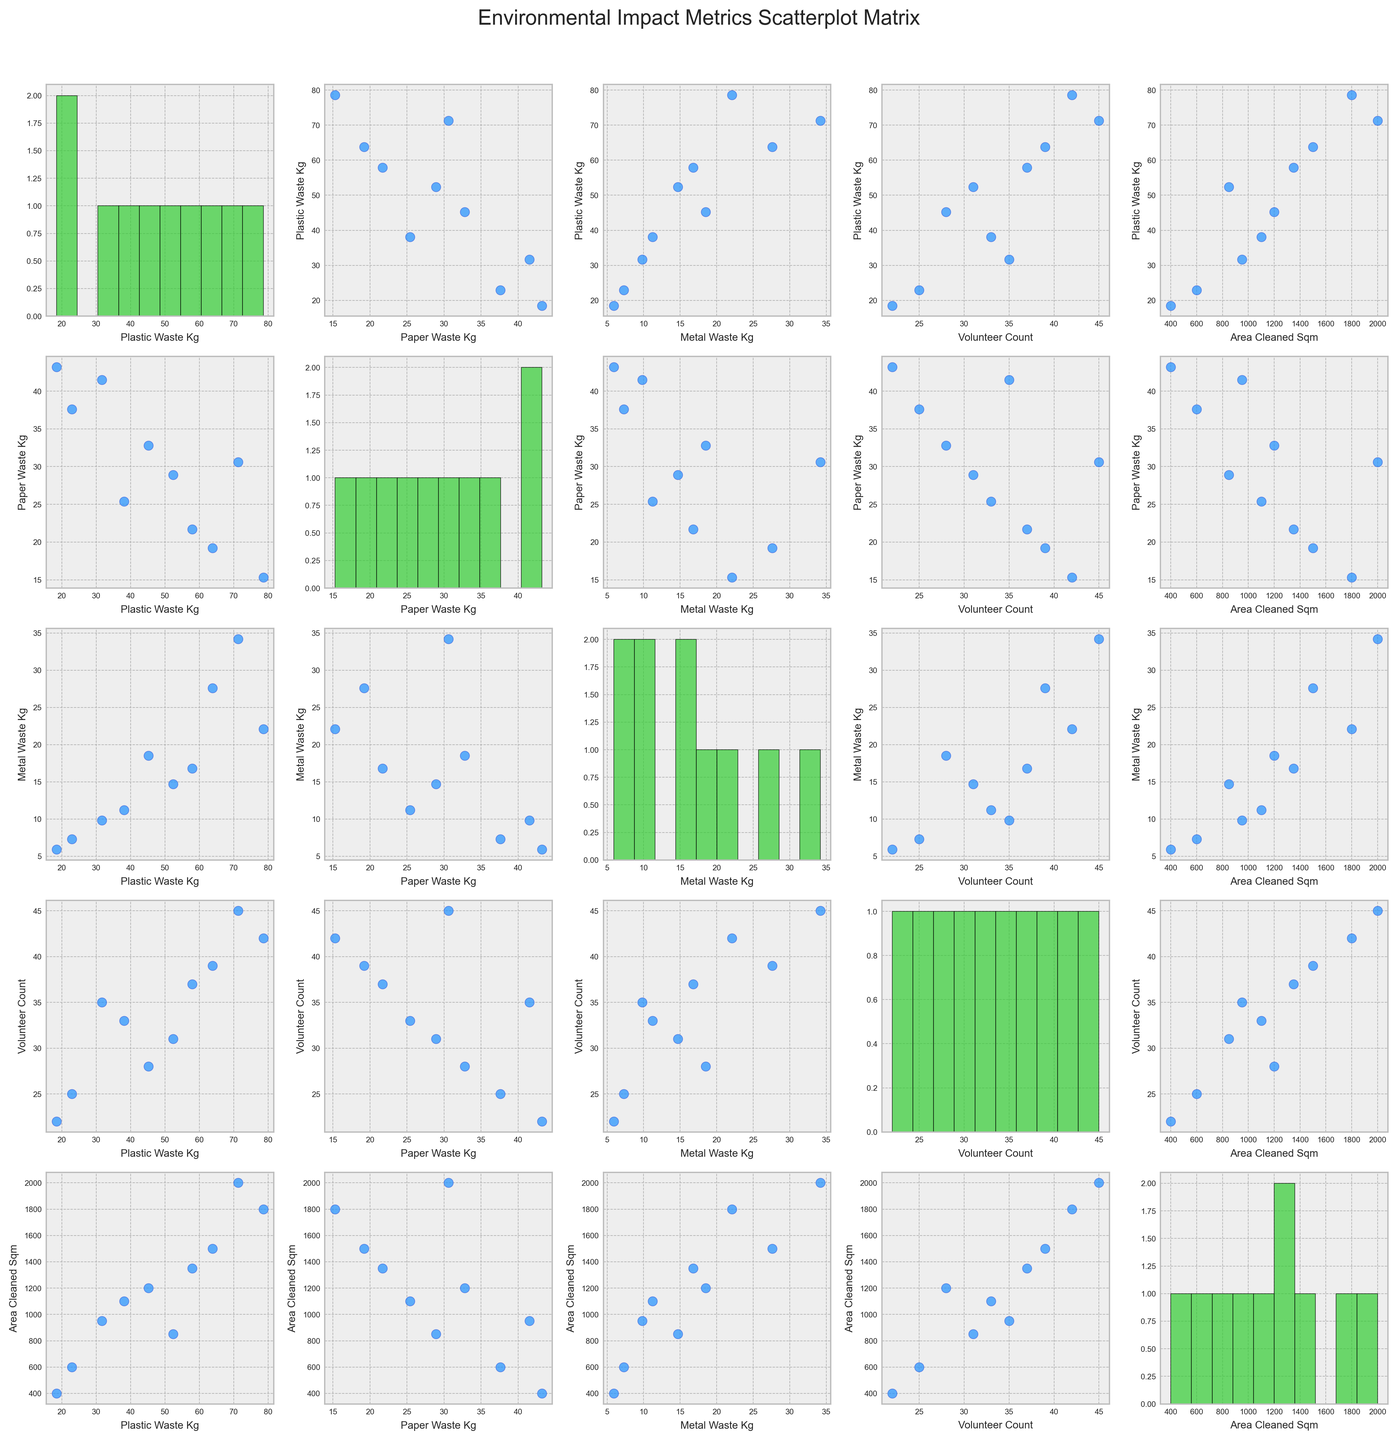What's the main color of the scatter points in the figure? The scatter points are mainly colored in shades of blue, which can be seen in the scatter plots comparing different metrics.
Answer: Blue What's the x-axis label when comparing Plastic Waste Kg to Volunteer Count? The x-axis label is "Volunteer Count" as seen in the scatter plot between Plastic_Waste_Kg and Volunteer_Count.
Answer: Volunteer Count How many scatter plots are there in the entire scatterplot matrix? The scatterplot matrix compares 5 variables, which means there are a 5x5 grid of plots. Since the diagonal contains histograms, there are 5 histograms and the rest are scatter plots. The total number of scatter plots is 5*5 - 5 = 20.
Answer: 20 Are the distributions of Plastic Waste Kg and Paper Waste Kg similar or different when looking at their histograms? The histogram for Plastic Waste Kg has a broad spread indicating more variability, while Paper Waste Kg shows two peaks, which could suggest a bimodal distribution. So, they are different.
Answer: Different Which event had the highest Volunteer Count and how does that correlate with Area Cleaned Sqm in the scatter plot matrix? The event with the highest Volunteer Count is the "Industrial Area Sweep" with 45 volunteers. In the scatter plot comparing Volunteer Count and Area Cleaned Sqm, this point would likely show up at the high end of both axes, suggesting a positive correlation.
Answer: Industrial Area Sweep Is there any visual indication that more volunteers lead to more collected waste? By looking at scatter plots where Volunteer Count is on one axis and different waste types are on the other, points with higher Volunteer Counts (towards the right) often correspond with higher waste amounts, indicating a positive trend.
Answer: Yes Which metric shows the most spread in its histogram: Plastic Waste Kg, Paper Waste Kg, or Metal Waste Kg? Plastic Waste Kg shows the most spread in its histogram, with values ranging widely compared to Paper and Metal Waste.
Answer: Plastic Waste Kg Between Plastic Waste Kg and Metal Waste Kg, which one shows a clearer correlation with Area Cleaned Sqm? By examining scatter plots, the relationship between Plastic Waste Kg and Area Cleaned Sqm looks stronger and more positively correlated than Metal Waste Kg and Area Cleaned Sqm.
Answer: Plastic Waste Kg How does the scatter plot of Volunteer Count vs. Area Cleaned Sqm look? Could there be any outliers? The scatter plot of Volunteer Count vs. Area Cleaned Sqm shows a generally positive trend, with points spreading upwards to the right. The event "Downtown Blitz," for instance, might appear as an outlier if its Area Cleaned Sqm is significantly lower relative to its Volunteer Count.
Answer: Positive trend; possible outlier "Downtown Blitz" 